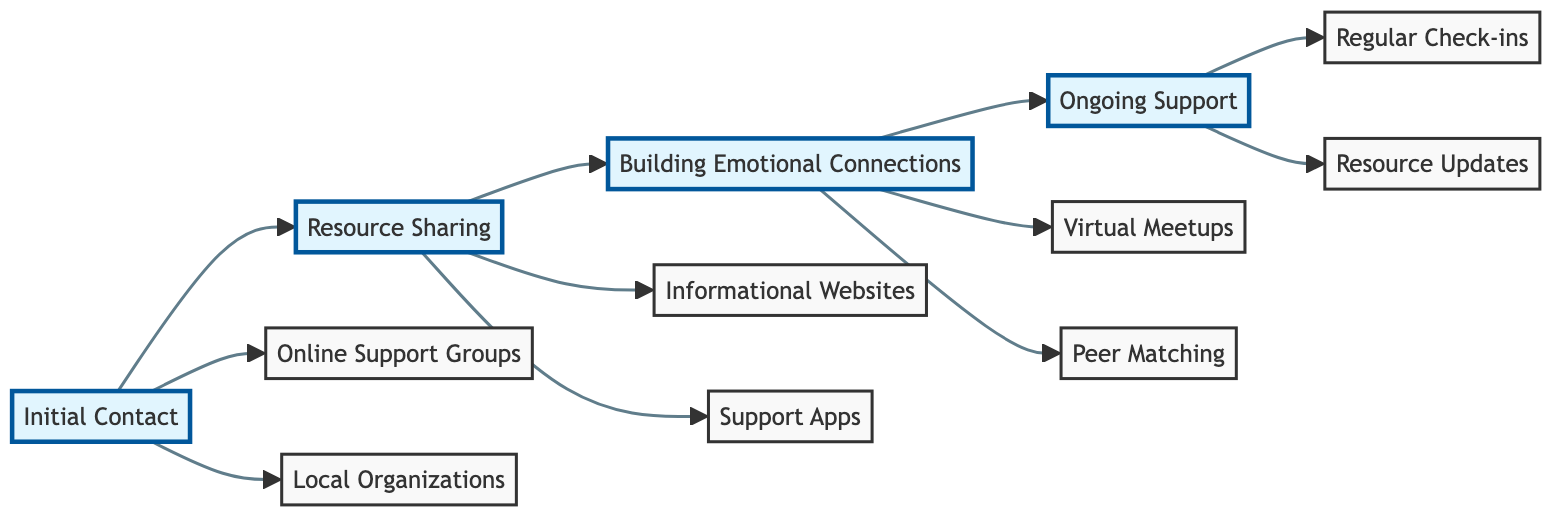What are the two options under Initial Contact? By checking the "Initial Contact" node, we see it branches out to "Online Support Groups" and "Local Organizations" which are the two specific pathways provided in that stage.
Answer: Online Support Groups, Local Organizations How many nodes are there in the diagram? Counting all distinct points in the diagram including phases and specific options, we find a total of 8 nodes: 4 phases and 4 specific options.
Answer: 8 What connects Resource Sharing to Building Emotional Connections? The flowchart shows an arrow from the "Resource Sharing" node to the "Building Emotional Connections" node, indicating a direct relationship where one aspect leads to another.
Answer: An arrow What is the third option listed under Ongoing Support? Looking at the "Ongoing Support" node, we can identify the two specific activities listed, i.e., "Regular Check-ins" and "Resource Updates," making it clear that "Regular Check-ins" is the first item and "Resource Updates" is the second; thus the third option is not applicable as there are only two.
Answer: Not applicable How does one progress from Initial Contact to Resource Sharing? By moving along the flowchart, we see that after the "Initial Contact" phase (with its two options), the next phase is "Resource Sharing," which indicates the natural progression in the support process for parents.
Answer: Directly What is the color coding for the Building Emotional Connections phase? The diagram uses a specific color scheme, where the "Building Emotional Connections" phase is highlighted with a yellow background representing the category of this phase.
Answer: Yellow How many ways are there to connect with others during Building Emotional Connections? Under "Building Emotional Connections," there are two options shown: "Virtual Meetups" and "Peer Matching." Therefore, there are two distinct ways to establish connection.
Answer: 2 What type of updates occur in Ongoing Support? The "Ongoing Support" node explicitly provides two types of updates: "Regular Check-ins" and "Resource Updates," indicating that ongoing support involves continuous communication and resource sharing.
Answer: Regular Check-ins, Resource Updates 